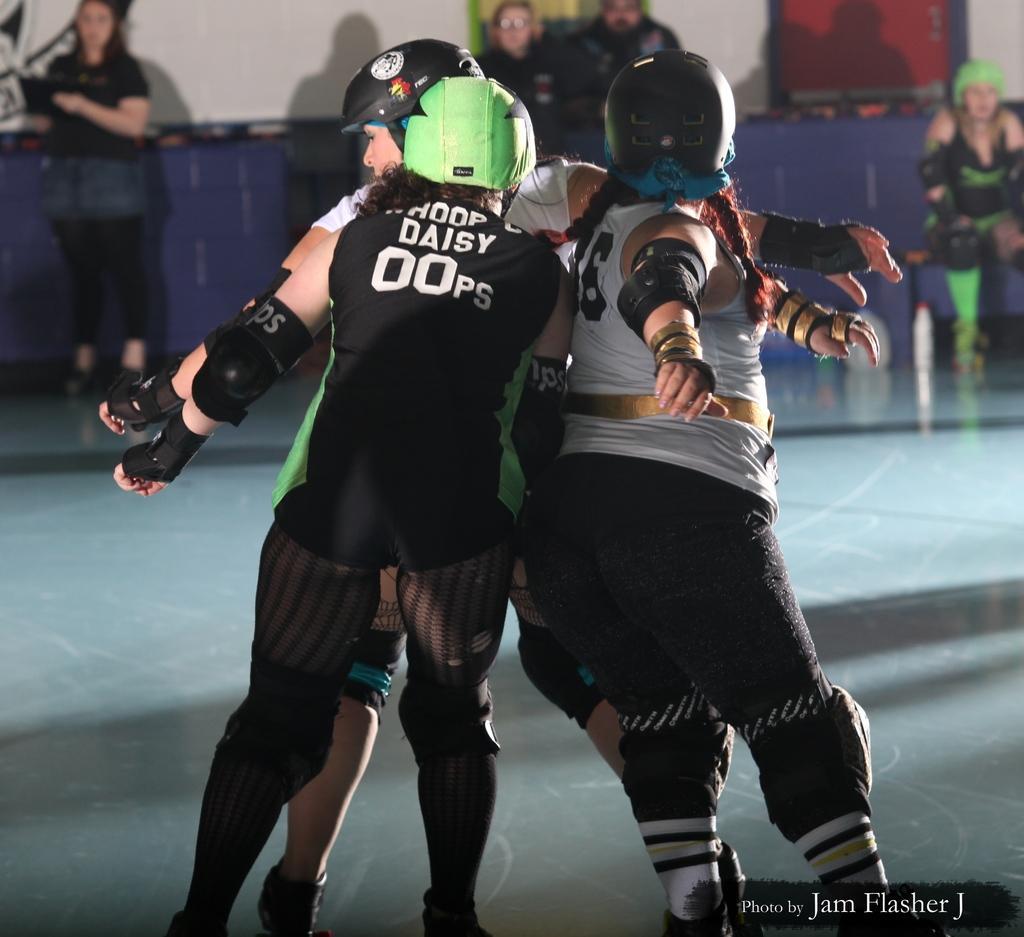Please provide a concise description of this image. As we can see in the image there are few people here and there and a white color wall. 